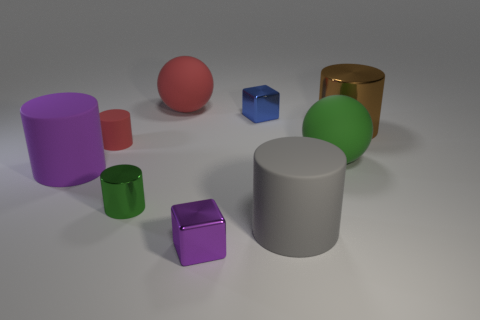How many large cyan matte objects are the same shape as the tiny matte thing?
Your answer should be compact. 0. There is a big ball on the left side of the tiny cube that is in front of the big matte sphere on the right side of the purple metallic block; what is its material?
Make the answer very short. Rubber. There is a tiny green thing; are there any metallic cylinders left of it?
Keep it short and to the point. No. What shape is the red thing that is the same size as the brown metal cylinder?
Your response must be concise. Sphere. Is the material of the gray cylinder the same as the red ball?
Your answer should be very brief. Yes. How many matte objects are small gray cubes or brown objects?
Make the answer very short. 0. What shape is the object that is the same color as the small rubber cylinder?
Give a very brief answer. Sphere. There is a matte ball in front of the big brown cylinder; is it the same color as the small metallic cylinder?
Ensure brevity in your answer.  Yes. What shape is the red thing that is in front of the metal block behind the gray rubber thing?
Offer a terse response. Cylinder. What number of things are either metallic objects that are on the right side of the small blue block or small cylinders that are in front of the small blue cube?
Give a very brief answer. 3. 